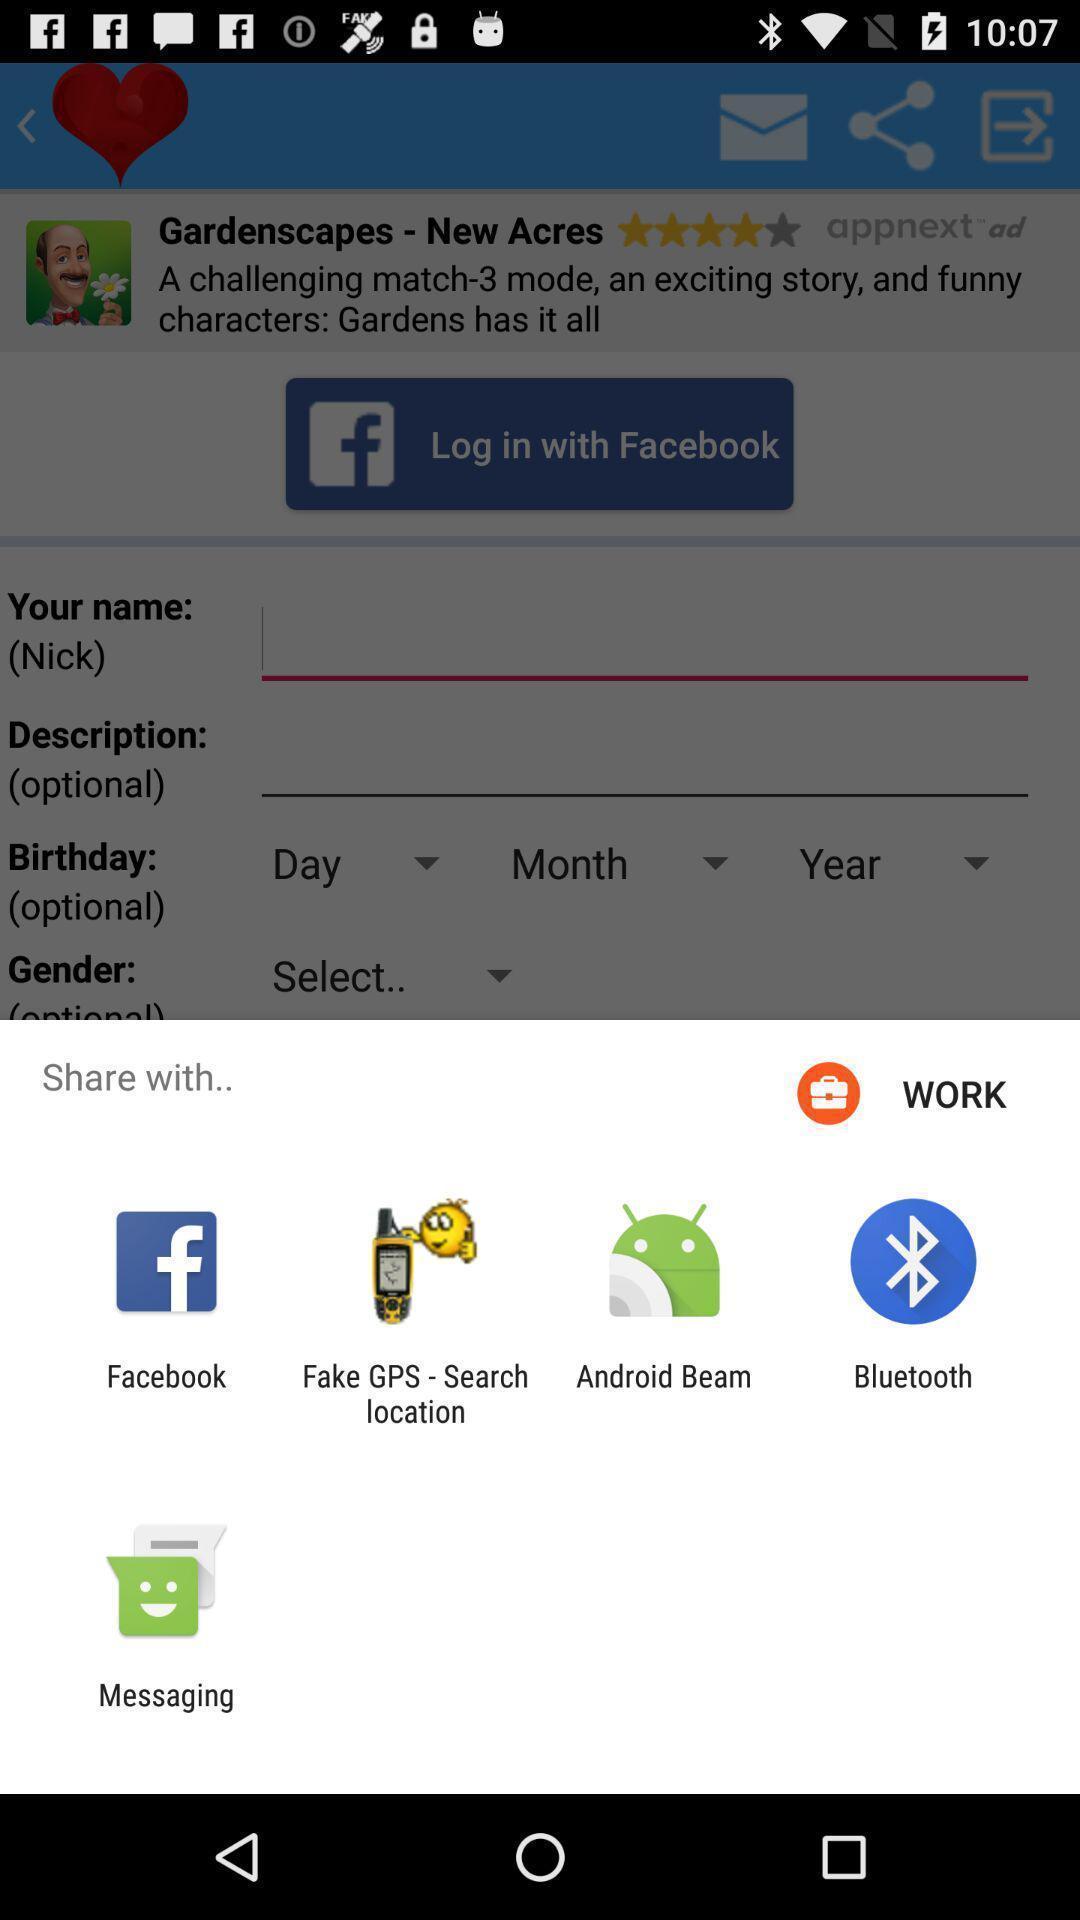Give me a summary of this screen capture. Share pop up with list of sharing options. 